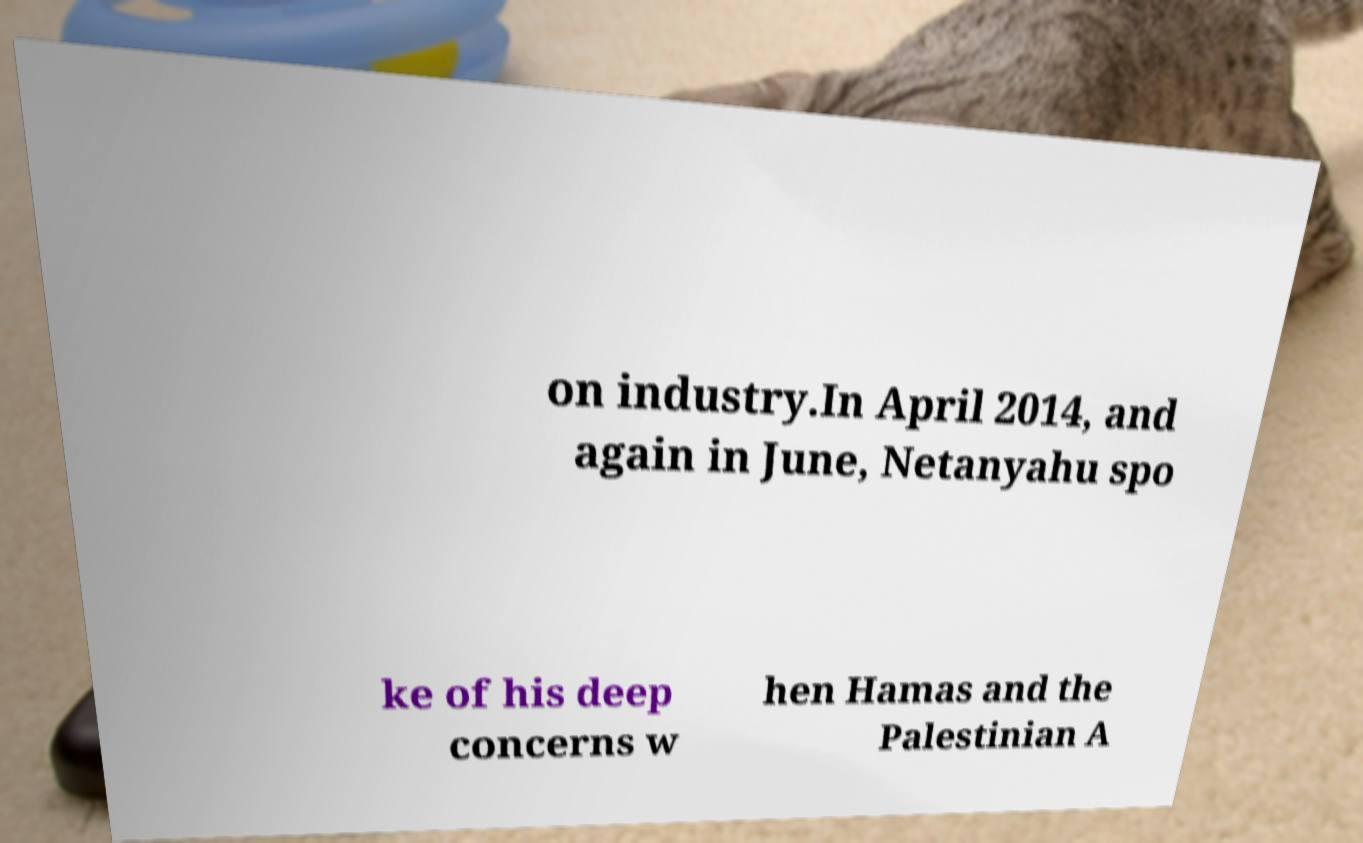Can you read and provide the text displayed in the image?This photo seems to have some interesting text. Can you extract and type it out for me? on industry.In April 2014, and again in June, Netanyahu spo ke of his deep concerns w hen Hamas and the Palestinian A 